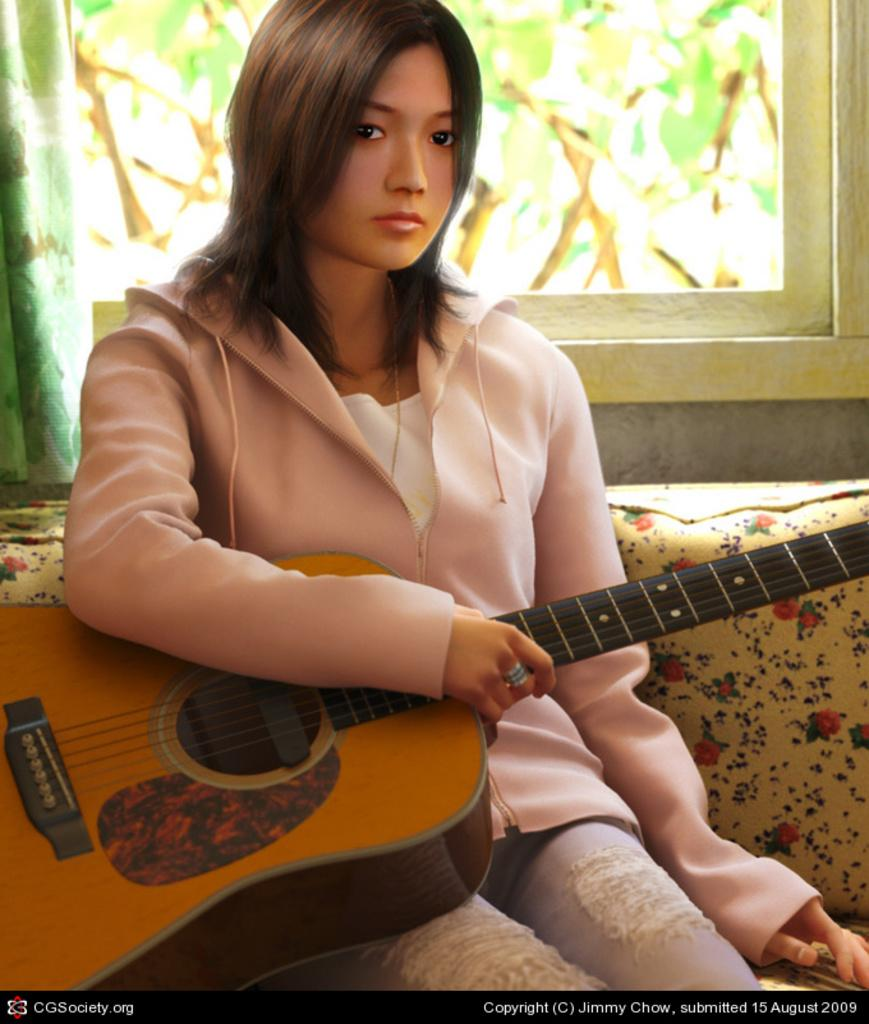Who is present in the image? There is a woman in the image. What is the woman doing in the image? The woman is sitting on a chair and holding a guitar in her hand. What can be seen in the background of the image? There is a window in the background of the image, and a curtain is associated with the window. What type of payment is the woman receiving for playing the guitar in the image? There is no indication in the image that the woman is receiving payment for playing the guitar, as the image does not show any transaction or exchange of money. 